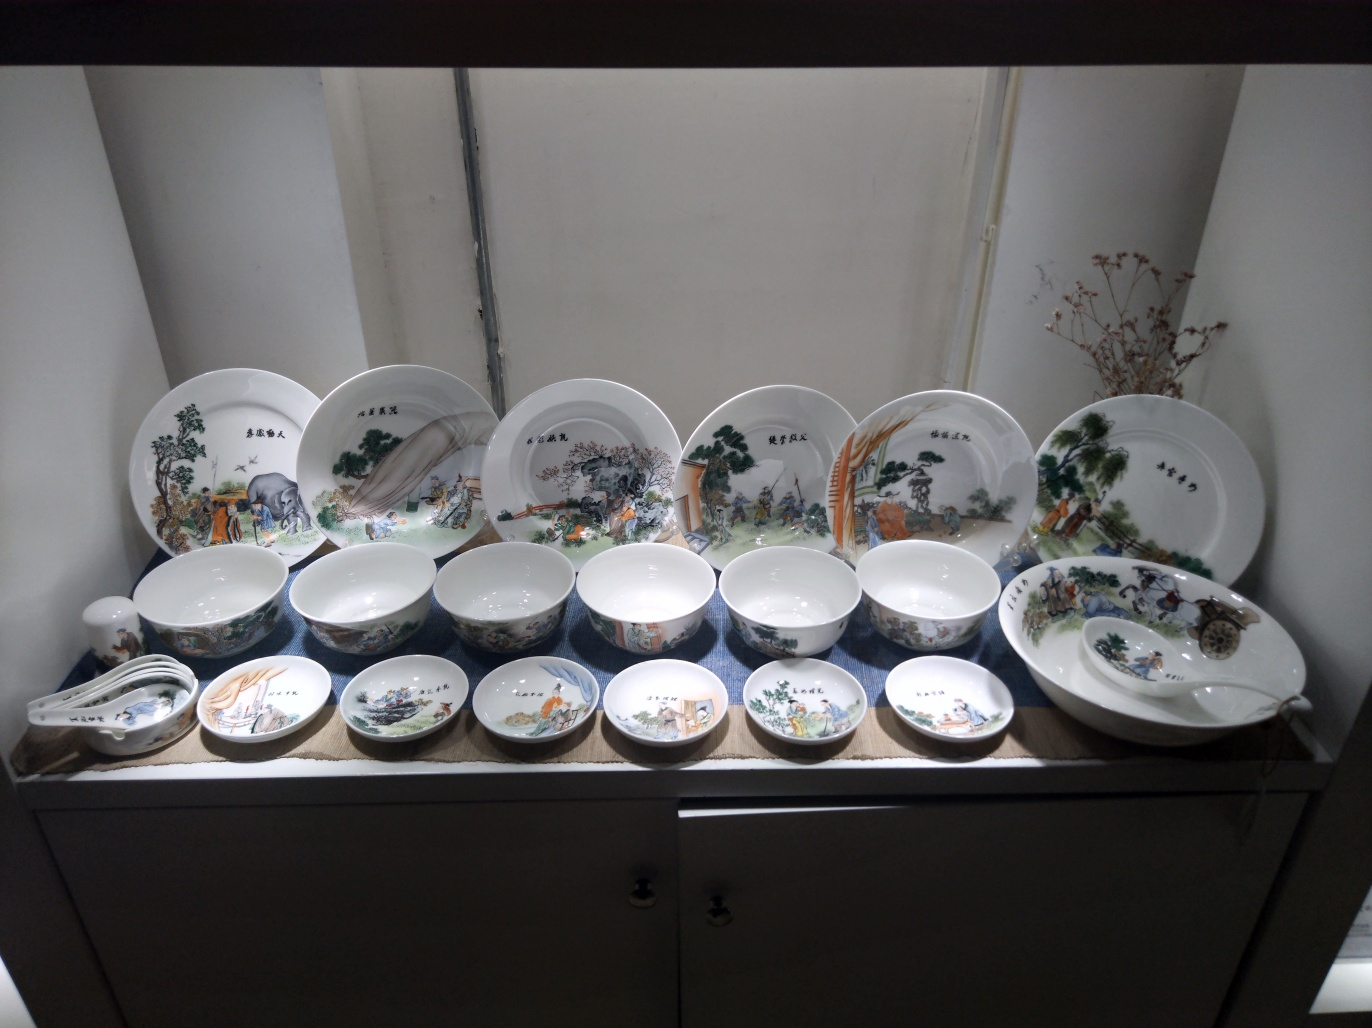What might this collection of dishware tell us about the culture it comes from? This collection likely reflects the values and aesthetics of its culture of origin, emphasizing harmony with nature and the importance of tradition. The pastoral themes suggest a reverence for the natural world and rural life. The meticulous craftsmanship points to a society that prizes detailed artistry and perhaps had a leisure class with the means to commission and appreciate such items. The use of traditional motifs and styles indicates a culture with a rich artistic heritage that is being preserved and continued through objects such as these. 